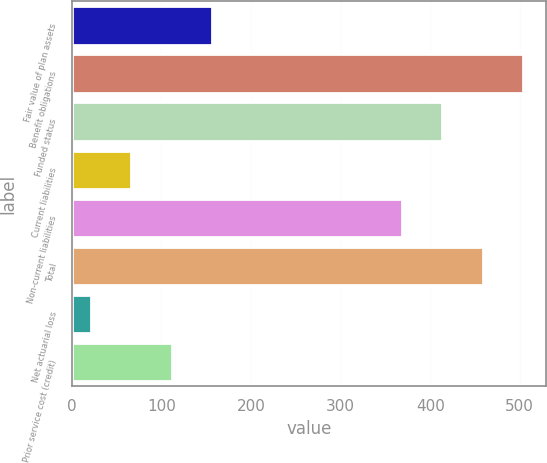<chart> <loc_0><loc_0><loc_500><loc_500><bar_chart><fcel>Fair value of plan assets<fcel>Benefit obligations<fcel>Funded status<fcel>Current liabilities<fcel>Non-current liabilities<fcel>Total<fcel>Net actuarial loss<fcel>Prior service cost (credit)<nl><fcel>156.6<fcel>503.6<fcel>413.2<fcel>66.2<fcel>368<fcel>458.4<fcel>21<fcel>111.4<nl></chart> 